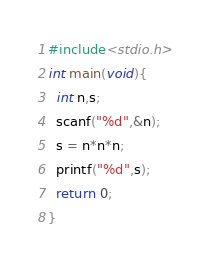<code> <loc_0><loc_0><loc_500><loc_500><_C_>#include<stdio.h>
int main(void){
  int n,s;
  scanf("%d",&n);
  s = n*n*n;
  printf("%d",s);
  return 0;
}</code> 